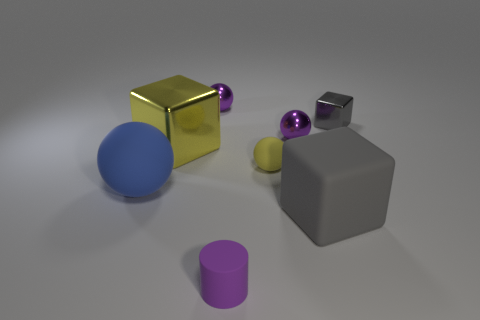What shape is the large gray rubber object to the right of the big yellow metal object?
Offer a terse response. Cube. How many gray things are there?
Make the answer very short. 2. Is the blue object made of the same material as the small yellow ball?
Ensure brevity in your answer.  Yes. Are there more large objects that are to the right of the small gray metal cube than purple rubber spheres?
Your answer should be compact. No. How many things are either red rubber things or shiny spheres that are left of the purple matte cylinder?
Your answer should be very brief. 1. Are there more gray objects behind the small gray shiny cube than purple spheres in front of the small cylinder?
Ensure brevity in your answer.  No. What material is the big cube that is on the left side of the small purple thing behind the purple object that is right of the tiny matte cylinder made of?
Provide a succinct answer. Metal. There is a blue object that is made of the same material as the large gray thing; what is its shape?
Your answer should be very brief. Sphere. There is a tiny rubber thing that is to the left of the yellow rubber object; are there any tiny shiny things on the right side of it?
Offer a terse response. Yes. The blue sphere is what size?
Your answer should be very brief. Large. 